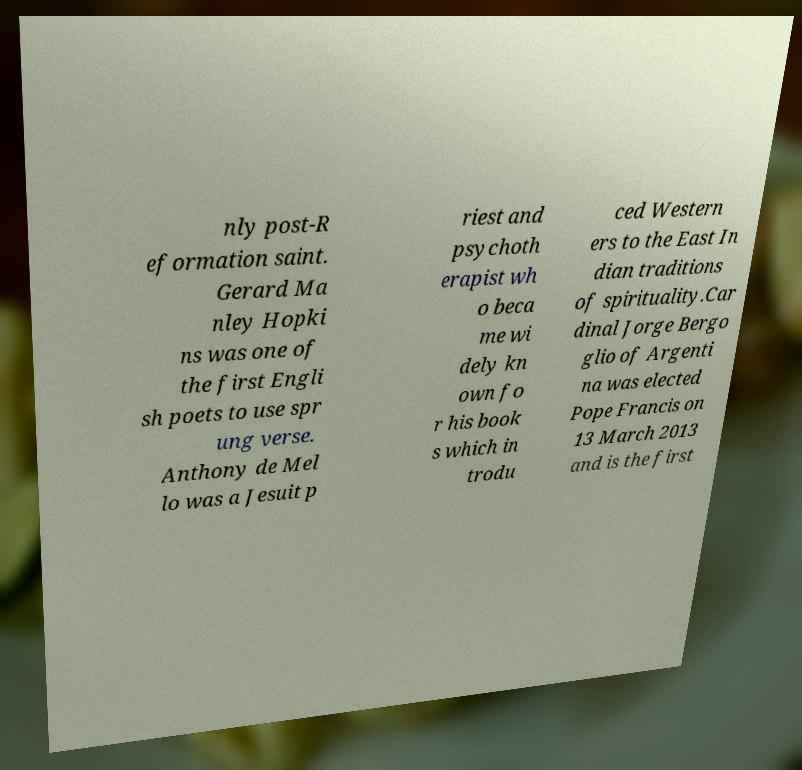Please read and relay the text visible in this image. What does it say? nly post-R eformation saint. Gerard Ma nley Hopki ns was one of the first Engli sh poets to use spr ung verse. Anthony de Mel lo was a Jesuit p riest and psychoth erapist wh o beca me wi dely kn own fo r his book s which in trodu ced Western ers to the East In dian traditions of spirituality.Car dinal Jorge Bergo glio of Argenti na was elected Pope Francis on 13 March 2013 and is the first 